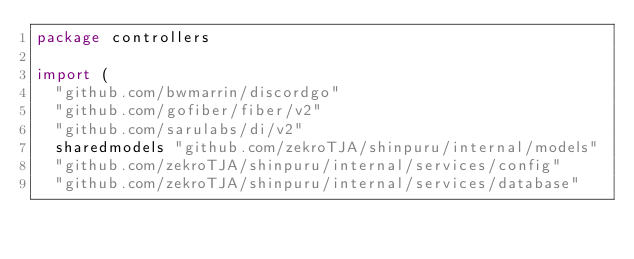<code> <loc_0><loc_0><loc_500><loc_500><_Go_>package controllers

import (
	"github.com/bwmarrin/discordgo"
	"github.com/gofiber/fiber/v2"
	"github.com/sarulabs/di/v2"
	sharedmodels "github.com/zekroTJA/shinpuru/internal/models"
	"github.com/zekroTJA/shinpuru/internal/services/config"
	"github.com/zekroTJA/shinpuru/internal/services/database"</code> 